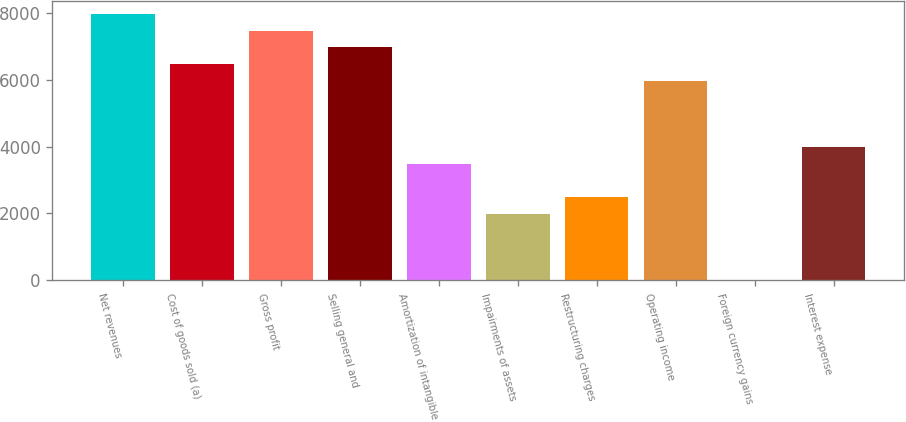<chart> <loc_0><loc_0><loc_500><loc_500><bar_chart><fcel>Net revenues<fcel>Cost of goods sold (a)<fcel>Gross profit<fcel>Selling general and<fcel>Amortization of intangible<fcel>Impairments of assets<fcel>Restructuring charges<fcel>Operating income<fcel>Foreign currency gains<fcel>Interest expense<nl><fcel>7964.92<fcel>6471.91<fcel>7467.25<fcel>6969.58<fcel>3485.89<fcel>1992.88<fcel>2490.55<fcel>5974.24<fcel>2.2<fcel>3983.56<nl></chart> 